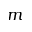Convert formula to latex. <formula><loc_0><loc_0><loc_500><loc_500>m</formula> 